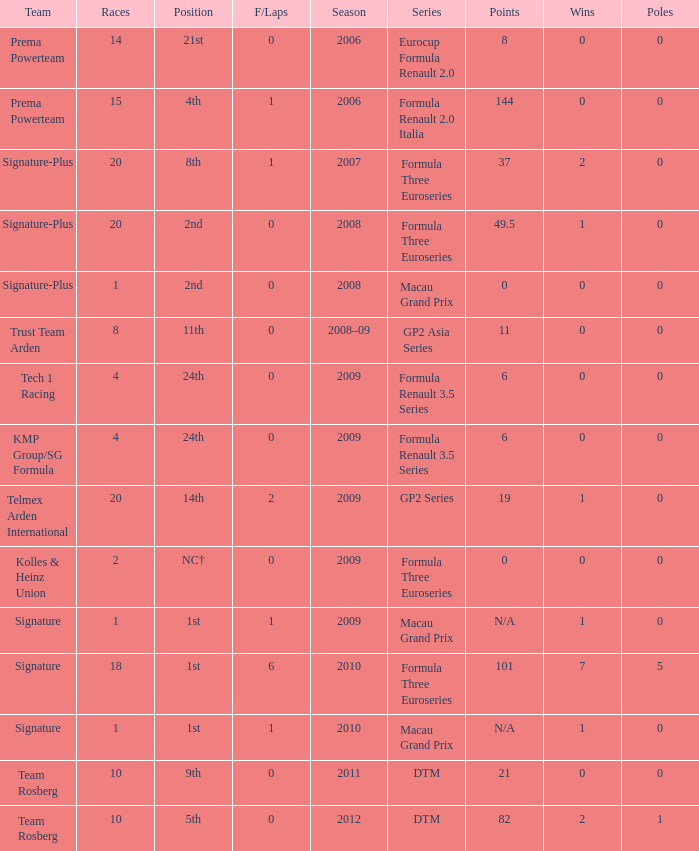How many poles are there in the 2009 season with 2 races and more than 0 F/Laps? 0.0. 